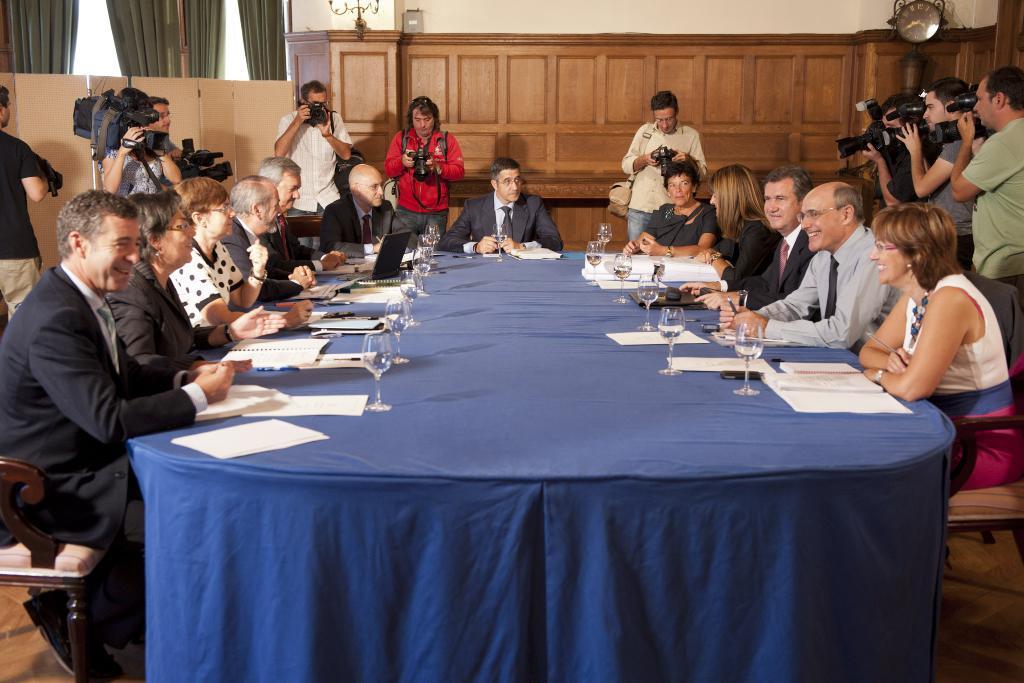Could you give a brief overview of what you see in this image? This is a conference room. here we can see few persons sitting on chairs infront of a tble and on the table we can see books, papers, penn and glass of water. This is a blue color cloth on the table. This is a floor. We can see few persons standing around these persons and recording. This is a clock. This are curtains. These are cupboards. This is a wall. 